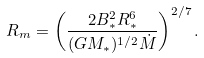<formula> <loc_0><loc_0><loc_500><loc_500>R _ { m } = \left ( \frac { 2 B _ { * } ^ { 2 } R _ { * } ^ { 6 } } { ( G M _ { * } ) ^ { 1 / 2 } \dot { M } } \right ) ^ { 2 / 7 } .</formula> 